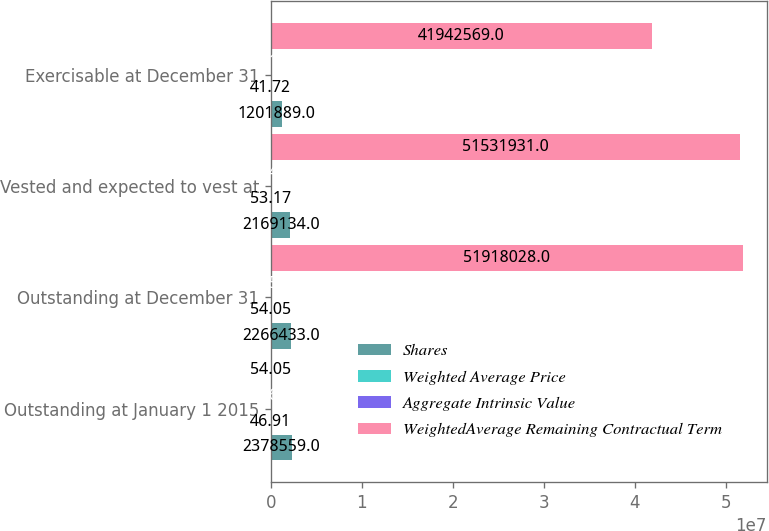<chart> <loc_0><loc_0><loc_500><loc_500><stacked_bar_chart><ecel><fcel>Outstanding at January 1 2015<fcel>Outstanding at December 31<fcel>Vested and expected to vest at<fcel>Exercisable at December 31<nl><fcel>Shares<fcel>2.37856e+06<fcel>2.26643e+06<fcel>2.16913e+06<fcel>1.20189e+06<nl><fcel>Weighted Average Price<fcel>46.91<fcel>54.05<fcel>53.17<fcel>41.72<nl><fcel>Aggregate Intrinsic Value<fcel>6.69<fcel>6.58<fcel>6.48<fcel>5.13<nl><fcel>WeightedAverage Remaining Contractual Term<fcel>54.05<fcel>5.1918e+07<fcel>5.15319e+07<fcel>4.19426e+07<nl></chart> 